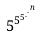Convert formula to latex. <formula><loc_0><loc_0><loc_500><loc_500>5 ^ { 5 ^ { 5 ^ { . ^ { . ^ { n } } } } }</formula> 